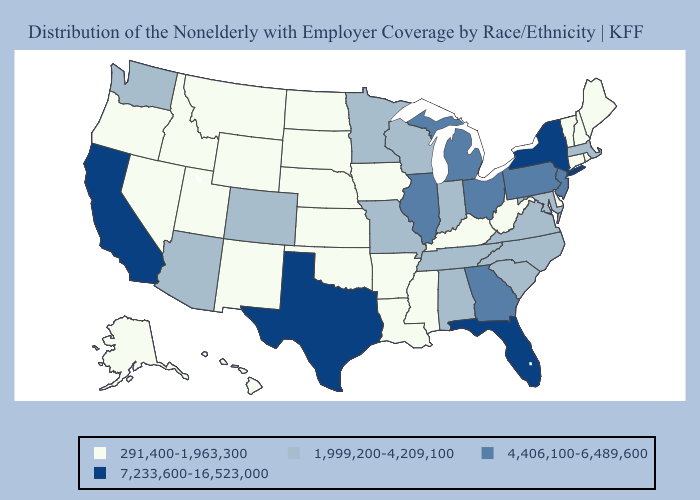Does Mississippi have a higher value than North Dakota?
Keep it brief. No. Name the states that have a value in the range 291,400-1,963,300?
Give a very brief answer. Alaska, Arkansas, Connecticut, Delaware, Hawaii, Idaho, Iowa, Kansas, Kentucky, Louisiana, Maine, Mississippi, Montana, Nebraska, Nevada, New Hampshire, New Mexico, North Dakota, Oklahoma, Oregon, Rhode Island, South Dakota, Utah, Vermont, West Virginia, Wyoming. What is the highest value in states that border Vermont?
Give a very brief answer. 7,233,600-16,523,000. Does Pennsylvania have the highest value in the USA?
Concise answer only. No. What is the value of Rhode Island?
Quick response, please. 291,400-1,963,300. Does Massachusetts have the lowest value in the USA?
Short answer required. No. What is the highest value in the MidWest ?
Keep it brief. 4,406,100-6,489,600. What is the highest value in the South ?
Give a very brief answer. 7,233,600-16,523,000. Name the states that have a value in the range 7,233,600-16,523,000?
Be succinct. California, Florida, New York, Texas. Does North Carolina have the highest value in the South?
Concise answer only. No. Which states hav the highest value in the Northeast?
Be succinct. New York. What is the lowest value in the Northeast?
Keep it brief. 291,400-1,963,300. Name the states that have a value in the range 1,999,200-4,209,100?
Keep it brief. Alabama, Arizona, Colorado, Indiana, Maryland, Massachusetts, Minnesota, Missouri, North Carolina, South Carolina, Tennessee, Virginia, Washington, Wisconsin. What is the value of South Dakota?
Give a very brief answer. 291,400-1,963,300. 